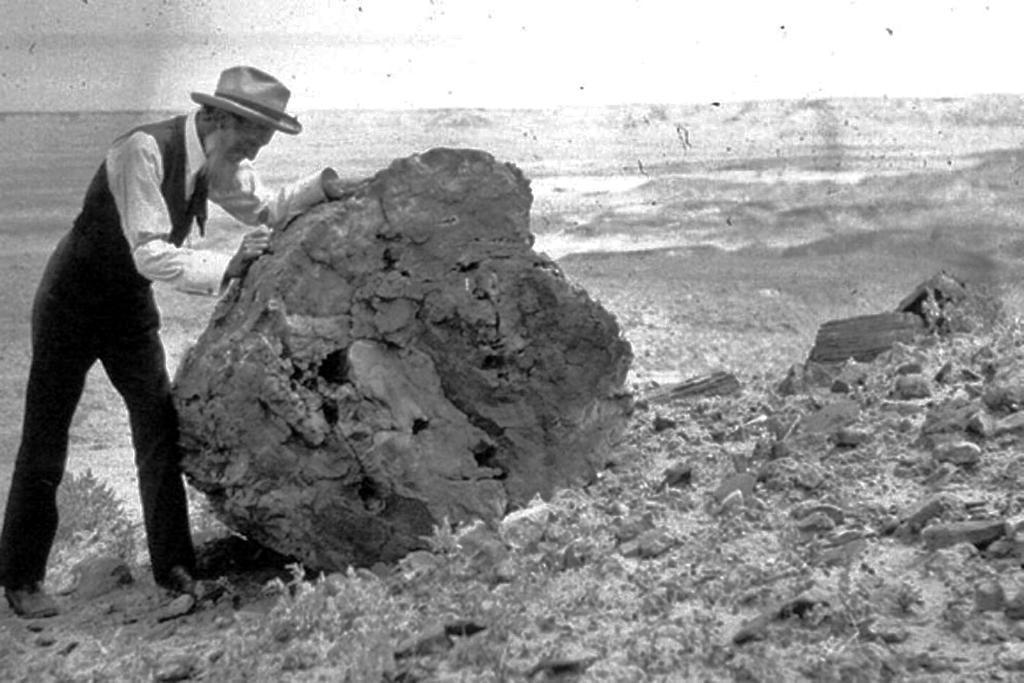Can you describe this image briefly? This is a black and white image. In this image we can see a person wearing hat standing beside a rock keeping his hands on it. We can also see some stones on the ground. 